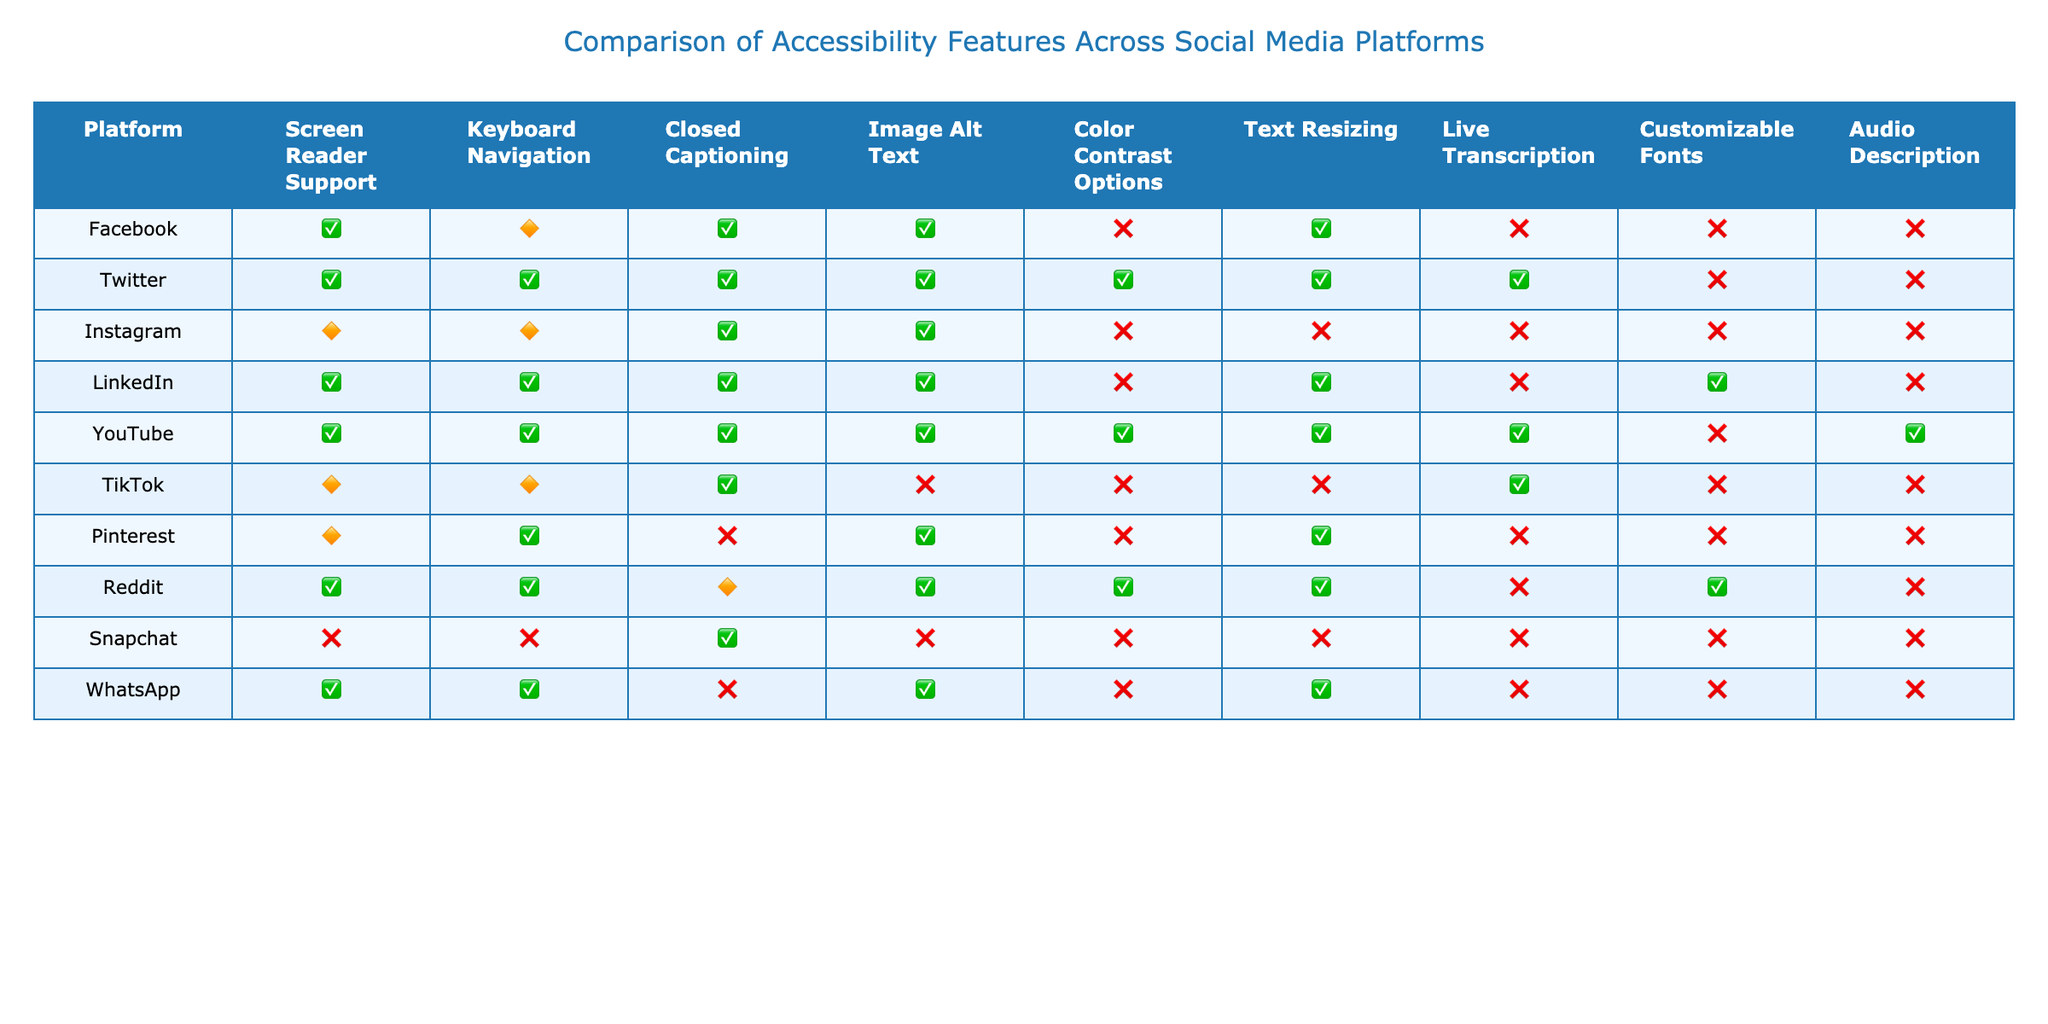What's the accessibility feature that Facebook does not support? Facebook does not support Color Contrast Options, as indicated by the "No" value in that column.
Answer: Color Contrast Options Which platforms have full Screen Reader Support? The platforms with full Screen Reader Support are Twitter, LinkedIn, YouTube, and Reddit, shown by "Yes" values under Screen Reader Support.
Answer: Twitter, LinkedIn, YouTube, Reddit How many platforms offer Keyboard Navigation? Counting the "Yes" values under the Keyboard Navigation column: Twitter, LinkedIn, Pinterest, and Reddit offer full support, resulting in a total of 4 platforms.
Answer: 4 Is Closed Captioning available on Snapchat? Snapchat has "No" listed for Closed Captioning, indicating that it does not support this feature.
Answer: No Which platform offers the most accessibility features? YouTube has "Yes" for seven features, making it the platform with the most accessibility features available.
Answer: YouTube Are there any platforms that do not support Live Transcription? Five platforms do not support Live Transcription: Facebook, Instagram, Pinterest, Snapchat, and WhatsApp, as their values in that column are either "No" or "Partial."
Answer: Yes What is the ratio of platforms that fully support Image Alt Text to those that do not? Platforms that fully support Image Alt Text are Facebook, Twitter, Instagram, LinkedIn, and Reddit, totaling 5, while Snapchat, TikTok, and YouTube do not, giving us a count of 3. Therefore, the ratio is 5:3.
Answer: 5:3 Which platform has partial support for both Screen Reader and Keyboard Navigation? Instagram and TikTok both have "Partial" support for Screen Reader and Keyboard Navigation features, respectively.
Answer: Instagram, TikTok How does the support for Audio Description compare between Facebook and YouTube? Facebook does not support Audio Description ("No") while YouTube offers it ("Yes"), indicating that YouTube has the feature while Facebook does not.
Answer: YouTube has it, Facebook does not How many accessibility features does WhatsApp support compared to TikTok? WhatsApp supports 5 features (Yes), while TikTok supports only 4 features (including 2 Partial), showing that WhatsApp has more supported features.
Answer: WhatsApp has more features 